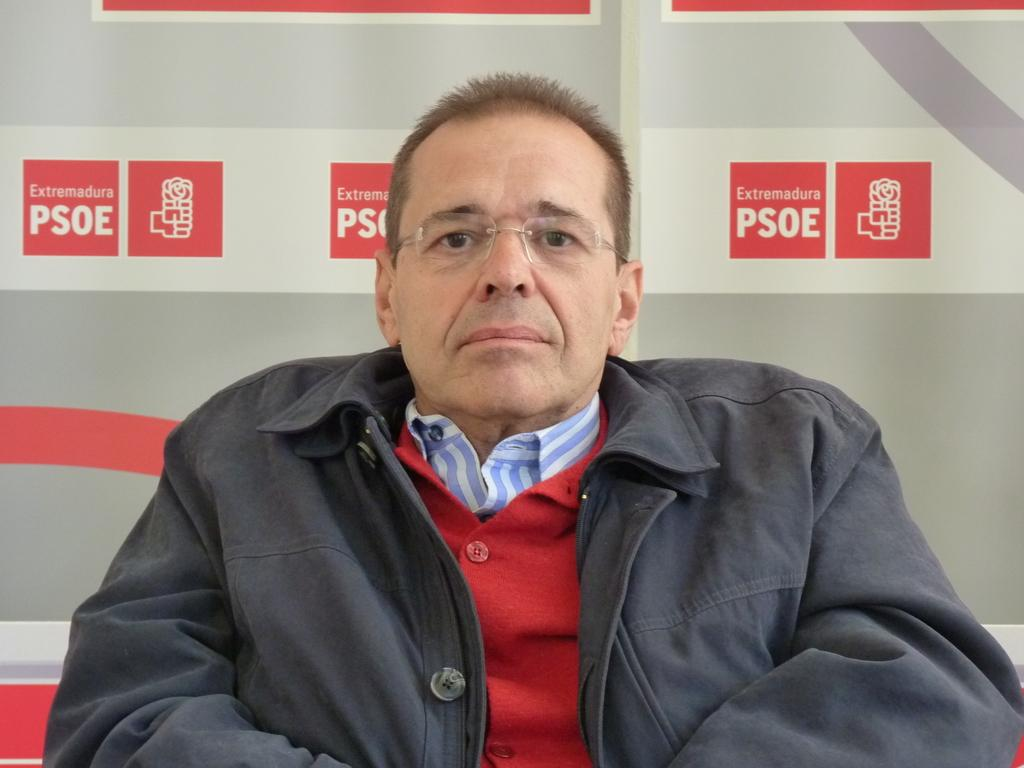What is the main subject of the image? There is a person in the image. What is the person doing in the image? The person is watching something. Can you describe the person's appearance? The person is wearing glasses. What can be seen in the background of the image? There is a banner in the background of the image. How many frogs are sitting on the person's shoulder in the image? There are no frogs present in the image. Can you describe the person's partner in the image? There is no partner mentioned or visible in the image. 